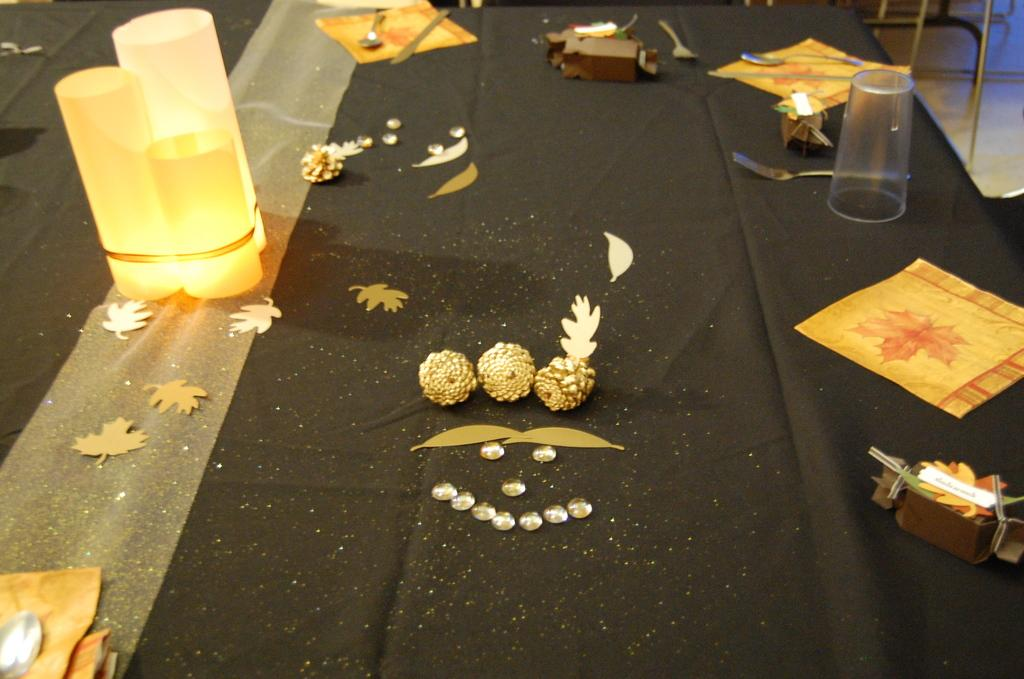What objects can be seen on the table in the image? There are lights, spoons, a glass, papers, and decor items on the table in the image. What type of utensils are present on the table? Spoons are present on the table. What can be used for drinking in the image? There is a glass on the table that can be used for drinking. What might be used for writing or reading in the image? Papers are present on the table, which might be used for writing or reading. What type of decorative items are on the table? There are decor items on the table. What is visible in the background of the image? There are stands in the background. What surface is visible in the image? There is a floor visible in the image. What type of partner is sitting next to the person in the image? There is no person or partner present in the image; it only shows objects on a table. How many spoons are being used to stir the loss in the image? There is no loss or stirring activity present in the image; it only shows objects on a table. 